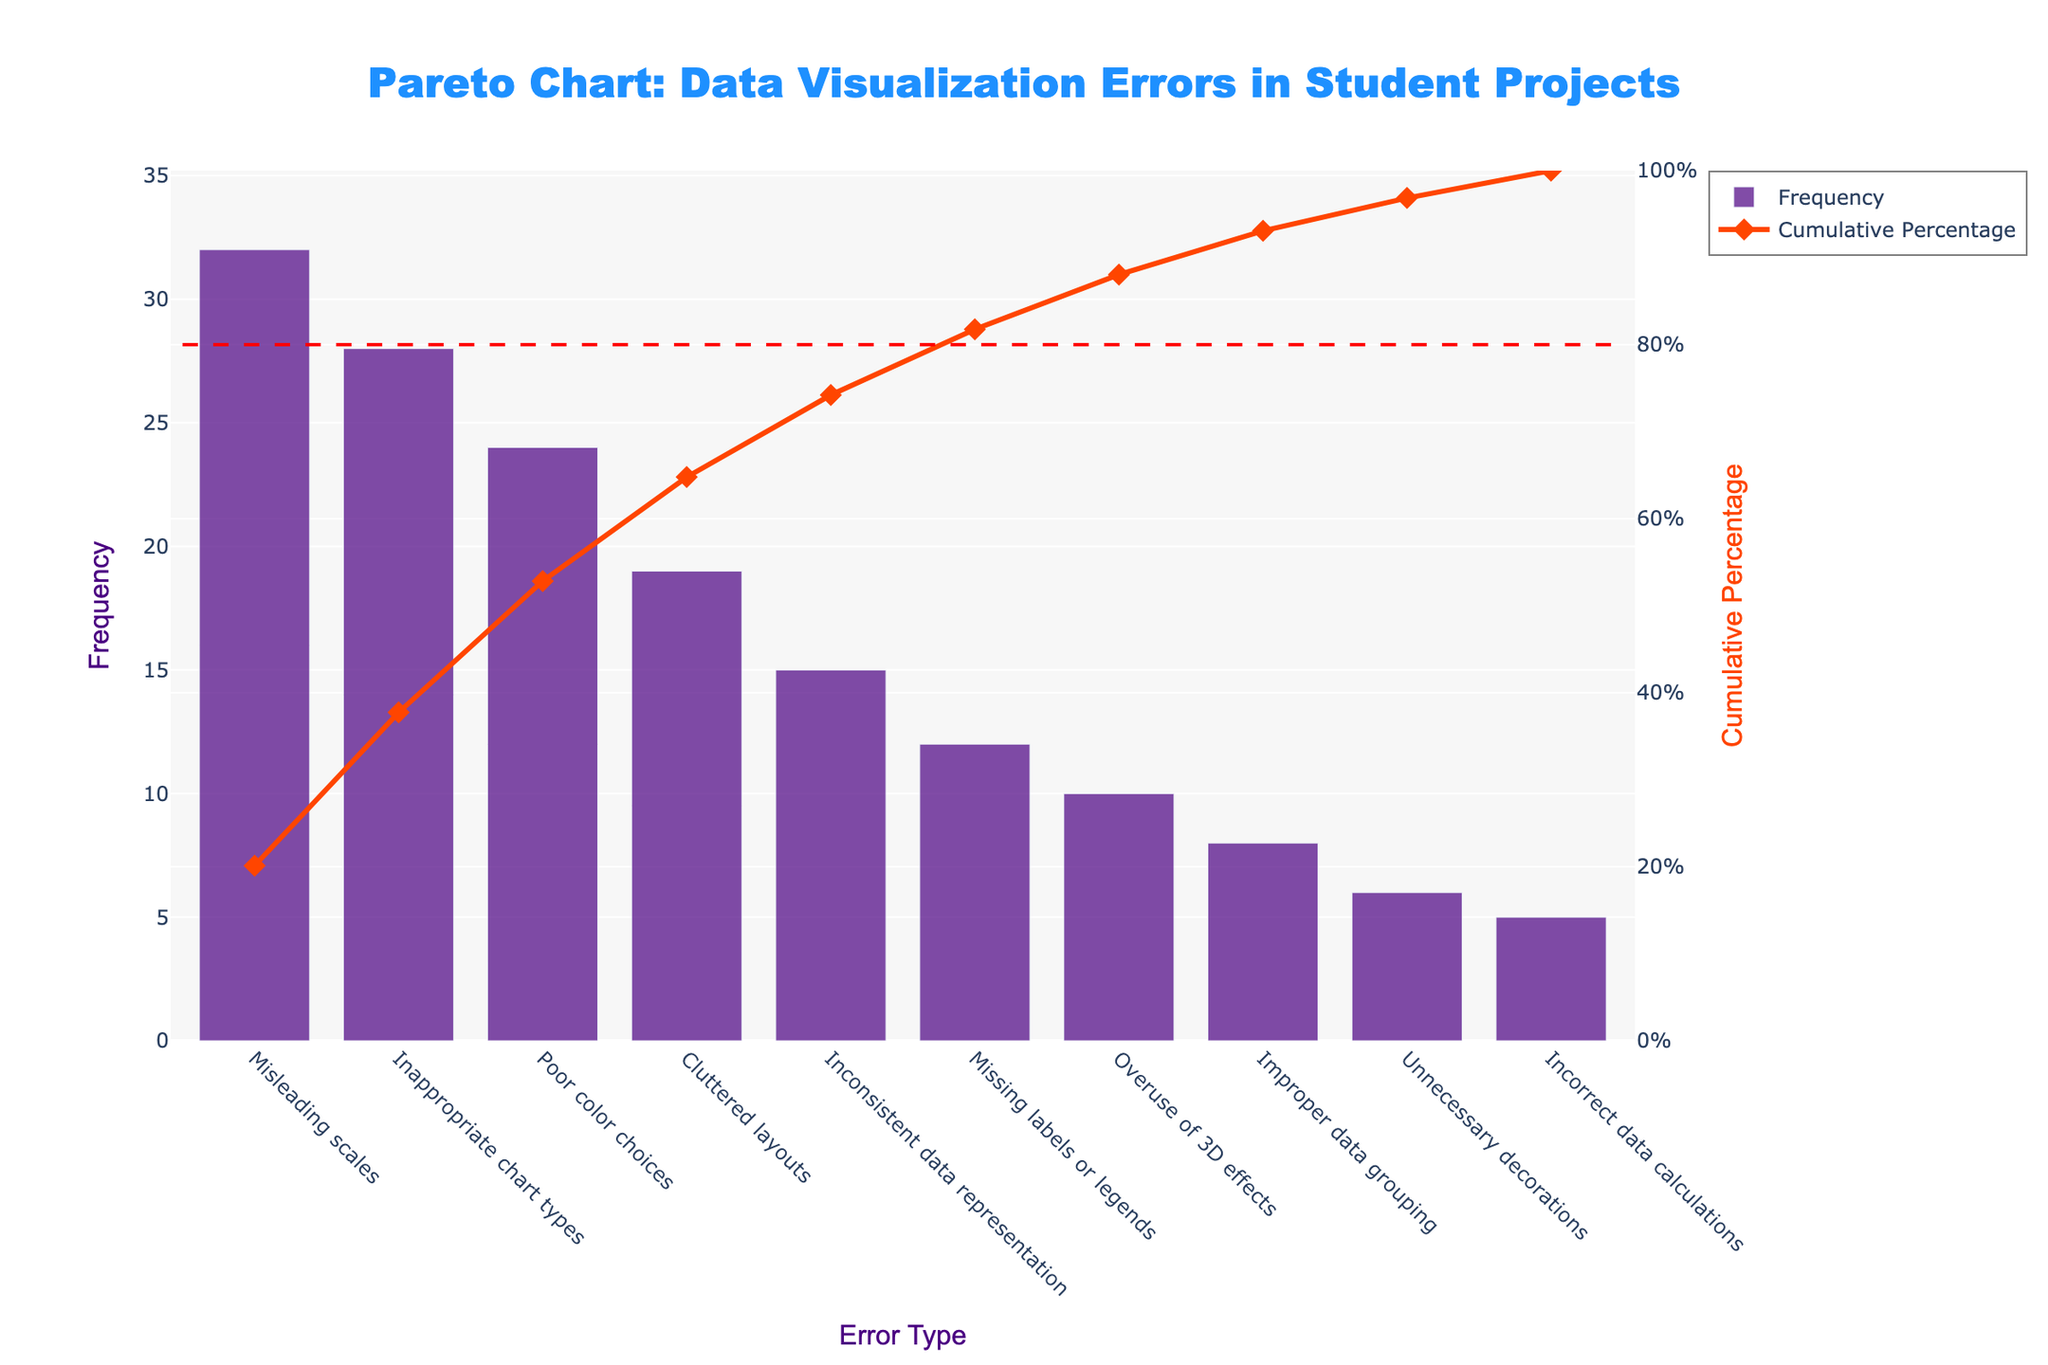How many types of data visualization errors are shown in the figure? The x-axis labels indicate the different types of data visualization errors depicted in the chart. By counting these labels, we can determine the number of error types.
Answer: 10 Which error type has the highest frequency? The bar chart shows the frequency of each error type. The tallest bar represents the highest frequency.
Answer: Misleading scales Which error type has the lowest frequency? The bar chart shows the frequency of each error type. The shortest bar represents the lowest frequency.
Answer: Incorrect data calculations What is the cumulative percentage after including the top 3 error types? To find the cumulative percentage after the top 3 error types, we add their individual frequencies and divide by the total frequency, then multiply by 100 to get the percentage. Specifically, the top 3 errors are Misleading scales (32), Inappropriate chart types (28), and Poor color choices (24). Their sum is 32 + 28 + 24 = 84. The total frequency is 179. So, the cumulative percentage is \( \frac{84}{179} \times 100 \approx 46.93 \).
Answer: ~46.93% What is the cumulative percentage up to the error type 'Cluttered layouts'? The cumulative percentage line indicates how error types accumulate in percentage. The fourth error type (Cluttered layouts) has its corresponding value on the right y-axis (cumulative percentage) in the chart.
Answer: ~60.89% How many error types contribute to 80% of the total frequency? The reference line at 80% indicates the cumulative percentage. By counting the bars from left to right up to the intersection with the 80% line, we can determine the number of error types that contribute to this percentage.
Answer: ~6 Are there more error types with a frequency greater than 20 or less than 10? Compare the number of bars with a height greater than 20 with those less than 10. The figure shows three bars above the 20-mark and three bars below the 10-mark.
Answer: Equal What is the cumulative percentage for 'Overuse of 3D effects'? ‘Overuse of 3D effects’ and its cumulative percentage value can be found using the line chart. Locate the point corresponding to ‘Overuse of 3D effects’ and read its y-axis2 value.
Answer: ~79.89% What color is used for the bars representing the frequency of error types? The color of the bars can be identified by observing the visual appearance of the bar chart.
Answer: Indigo 